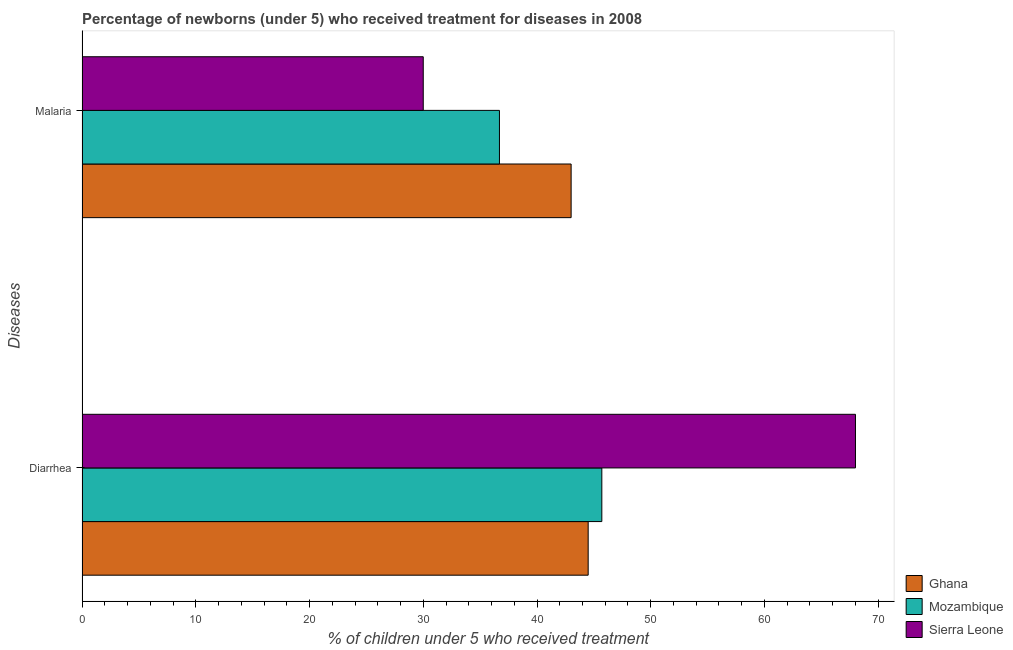Are the number of bars on each tick of the Y-axis equal?
Make the answer very short. Yes. How many bars are there on the 1st tick from the top?
Provide a succinct answer. 3. What is the label of the 1st group of bars from the top?
Provide a succinct answer. Malaria. What is the percentage of children who received treatment for malaria in Sierra Leone?
Provide a succinct answer. 30. Across all countries, what is the minimum percentage of children who received treatment for diarrhoea?
Give a very brief answer. 44.5. In which country was the percentage of children who received treatment for malaria maximum?
Offer a very short reply. Ghana. In which country was the percentage of children who received treatment for diarrhoea minimum?
Keep it short and to the point. Ghana. What is the total percentage of children who received treatment for malaria in the graph?
Your response must be concise. 109.7. What is the difference between the percentage of children who received treatment for diarrhoea in Sierra Leone and that in Mozambique?
Keep it short and to the point. 22.3. What is the difference between the percentage of children who received treatment for malaria in Mozambique and the percentage of children who received treatment for diarrhoea in Ghana?
Keep it short and to the point. -7.8. What is the average percentage of children who received treatment for malaria per country?
Keep it short and to the point. 36.57. What is the difference between the percentage of children who received treatment for malaria and percentage of children who received treatment for diarrhoea in Ghana?
Ensure brevity in your answer.  -1.5. In how many countries, is the percentage of children who received treatment for diarrhoea greater than 56 %?
Your response must be concise. 1. What is the ratio of the percentage of children who received treatment for malaria in Mozambique to that in Ghana?
Give a very brief answer. 0.85. Is the percentage of children who received treatment for malaria in Ghana less than that in Mozambique?
Ensure brevity in your answer.  No. What does the 3rd bar from the top in Malaria represents?
Provide a short and direct response. Ghana. What does the 3rd bar from the bottom in Malaria represents?
Give a very brief answer. Sierra Leone. How many bars are there?
Provide a short and direct response. 6. Where does the legend appear in the graph?
Your answer should be compact. Bottom right. How many legend labels are there?
Your answer should be compact. 3. What is the title of the graph?
Offer a very short reply. Percentage of newborns (under 5) who received treatment for diseases in 2008. Does "Latvia" appear as one of the legend labels in the graph?
Provide a succinct answer. No. What is the label or title of the X-axis?
Offer a terse response. % of children under 5 who received treatment. What is the label or title of the Y-axis?
Keep it short and to the point. Diseases. What is the % of children under 5 who received treatment of Ghana in Diarrhea?
Provide a short and direct response. 44.5. What is the % of children under 5 who received treatment in Mozambique in Diarrhea?
Ensure brevity in your answer.  45.7. What is the % of children under 5 who received treatment of Mozambique in Malaria?
Provide a short and direct response. 36.7. What is the % of children under 5 who received treatment of Sierra Leone in Malaria?
Offer a terse response. 30. Across all Diseases, what is the maximum % of children under 5 who received treatment in Ghana?
Keep it short and to the point. 44.5. Across all Diseases, what is the maximum % of children under 5 who received treatment of Mozambique?
Offer a terse response. 45.7. Across all Diseases, what is the maximum % of children under 5 who received treatment in Sierra Leone?
Offer a terse response. 68. Across all Diseases, what is the minimum % of children under 5 who received treatment of Mozambique?
Make the answer very short. 36.7. Across all Diseases, what is the minimum % of children under 5 who received treatment of Sierra Leone?
Make the answer very short. 30. What is the total % of children under 5 who received treatment of Ghana in the graph?
Give a very brief answer. 87.5. What is the total % of children under 5 who received treatment in Mozambique in the graph?
Ensure brevity in your answer.  82.4. What is the difference between the % of children under 5 who received treatment in Mozambique in Diarrhea and that in Malaria?
Your answer should be very brief. 9. What is the difference between the % of children under 5 who received treatment of Sierra Leone in Diarrhea and that in Malaria?
Make the answer very short. 38. What is the difference between the % of children under 5 who received treatment in Ghana in Diarrhea and the % of children under 5 who received treatment in Mozambique in Malaria?
Ensure brevity in your answer.  7.8. What is the average % of children under 5 who received treatment in Ghana per Diseases?
Keep it short and to the point. 43.75. What is the average % of children under 5 who received treatment of Mozambique per Diseases?
Offer a terse response. 41.2. What is the average % of children under 5 who received treatment in Sierra Leone per Diseases?
Your response must be concise. 49. What is the difference between the % of children under 5 who received treatment of Ghana and % of children under 5 who received treatment of Sierra Leone in Diarrhea?
Offer a very short reply. -23.5. What is the difference between the % of children under 5 who received treatment of Mozambique and % of children under 5 who received treatment of Sierra Leone in Diarrhea?
Your answer should be very brief. -22.3. What is the difference between the % of children under 5 who received treatment in Ghana and % of children under 5 who received treatment in Mozambique in Malaria?
Your response must be concise. 6.3. What is the difference between the % of children under 5 who received treatment in Ghana and % of children under 5 who received treatment in Sierra Leone in Malaria?
Provide a short and direct response. 13. What is the ratio of the % of children under 5 who received treatment of Ghana in Diarrhea to that in Malaria?
Provide a succinct answer. 1.03. What is the ratio of the % of children under 5 who received treatment of Mozambique in Diarrhea to that in Malaria?
Your response must be concise. 1.25. What is the ratio of the % of children under 5 who received treatment of Sierra Leone in Diarrhea to that in Malaria?
Your response must be concise. 2.27. What is the difference between the highest and the second highest % of children under 5 who received treatment of Ghana?
Provide a succinct answer. 1.5. What is the difference between the highest and the second highest % of children under 5 who received treatment of Mozambique?
Offer a terse response. 9. What is the difference between the highest and the lowest % of children under 5 who received treatment of Mozambique?
Ensure brevity in your answer.  9. What is the difference between the highest and the lowest % of children under 5 who received treatment in Sierra Leone?
Your answer should be compact. 38. 